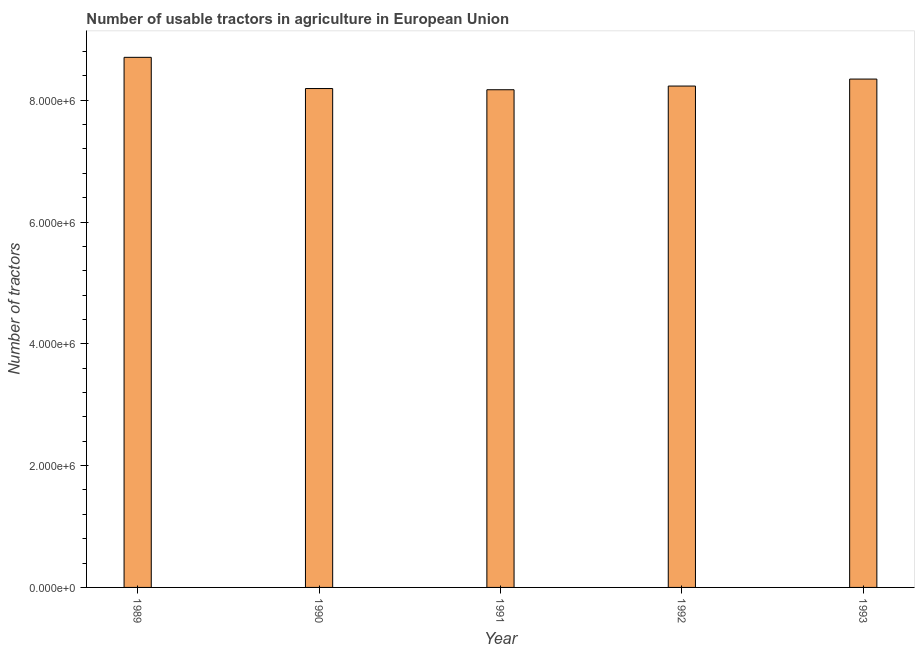Does the graph contain any zero values?
Offer a terse response. No. What is the title of the graph?
Your response must be concise. Number of usable tractors in agriculture in European Union. What is the label or title of the Y-axis?
Keep it short and to the point. Number of tractors. What is the number of tractors in 1991?
Your answer should be very brief. 8.17e+06. Across all years, what is the maximum number of tractors?
Ensure brevity in your answer.  8.70e+06. Across all years, what is the minimum number of tractors?
Your answer should be very brief. 8.17e+06. What is the sum of the number of tractors?
Your answer should be very brief. 4.16e+07. What is the difference between the number of tractors in 1989 and 1992?
Your response must be concise. 4.72e+05. What is the average number of tractors per year?
Make the answer very short. 8.33e+06. What is the median number of tractors?
Offer a terse response. 8.23e+06. In how many years, is the number of tractors greater than 2000000 ?
Offer a terse response. 5. Do a majority of the years between 1992 and 1989 (inclusive) have number of tractors greater than 3200000 ?
Keep it short and to the point. Yes. What is the ratio of the number of tractors in 1989 to that in 1993?
Your answer should be compact. 1.04. What is the difference between the highest and the second highest number of tractors?
Make the answer very short. 3.57e+05. Is the sum of the number of tractors in 1991 and 1992 greater than the maximum number of tractors across all years?
Your answer should be very brief. Yes. What is the difference between the highest and the lowest number of tractors?
Keep it short and to the point. 5.32e+05. In how many years, is the number of tractors greater than the average number of tractors taken over all years?
Offer a terse response. 2. How many bars are there?
Offer a very short reply. 5. Are all the bars in the graph horizontal?
Provide a short and direct response. No. How many years are there in the graph?
Provide a short and direct response. 5. What is the difference between two consecutive major ticks on the Y-axis?
Ensure brevity in your answer.  2.00e+06. Are the values on the major ticks of Y-axis written in scientific E-notation?
Provide a succinct answer. Yes. What is the Number of tractors in 1989?
Offer a very short reply. 8.70e+06. What is the Number of tractors of 1990?
Keep it short and to the point. 8.19e+06. What is the Number of tractors in 1991?
Give a very brief answer. 8.17e+06. What is the Number of tractors of 1992?
Your response must be concise. 8.23e+06. What is the Number of tractors of 1993?
Your answer should be very brief. 8.35e+06. What is the difference between the Number of tractors in 1989 and 1990?
Provide a succinct answer. 5.12e+05. What is the difference between the Number of tractors in 1989 and 1991?
Offer a terse response. 5.32e+05. What is the difference between the Number of tractors in 1989 and 1992?
Make the answer very short. 4.72e+05. What is the difference between the Number of tractors in 1989 and 1993?
Your answer should be compact. 3.57e+05. What is the difference between the Number of tractors in 1990 and 1991?
Keep it short and to the point. 1.97e+04. What is the difference between the Number of tractors in 1990 and 1992?
Make the answer very short. -4.08e+04. What is the difference between the Number of tractors in 1990 and 1993?
Give a very brief answer. -1.55e+05. What is the difference between the Number of tractors in 1991 and 1992?
Offer a terse response. -6.05e+04. What is the difference between the Number of tractors in 1991 and 1993?
Your answer should be compact. -1.75e+05. What is the difference between the Number of tractors in 1992 and 1993?
Offer a terse response. -1.15e+05. What is the ratio of the Number of tractors in 1989 to that in 1990?
Offer a very short reply. 1.06. What is the ratio of the Number of tractors in 1989 to that in 1991?
Your response must be concise. 1.06. What is the ratio of the Number of tractors in 1989 to that in 1992?
Keep it short and to the point. 1.06. What is the ratio of the Number of tractors in 1989 to that in 1993?
Provide a short and direct response. 1.04. What is the ratio of the Number of tractors in 1990 to that in 1991?
Your answer should be compact. 1. What is the ratio of the Number of tractors in 1990 to that in 1993?
Your answer should be compact. 0.98. 